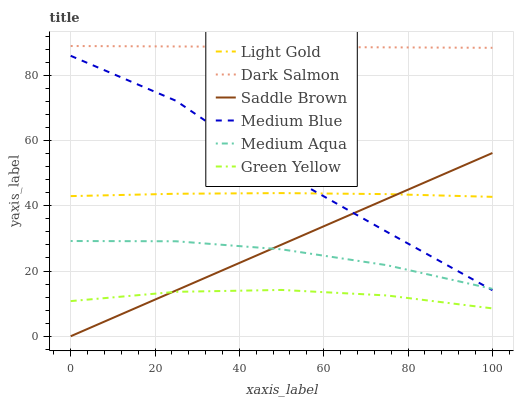Does Green Yellow have the minimum area under the curve?
Answer yes or no. Yes. Does Dark Salmon have the maximum area under the curve?
Answer yes or no. Yes. Does Medium Aqua have the minimum area under the curve?
Answer yes or no. No. Does Medium Aqua have the maximum area under the curve?
Answer yes or no. No. Is Dark Salmon the smoothest?
Answer yes or no. Yes. Is Medium Blue the roughest?
Answer yes or no. Yes. Is Medium Aqua the smoothest?
Answer yes or no. No. Is Medium Aqua the roughest?
Answer yes or no. No. Does Saddle Brown have the lowest value?
Answer yes or no. Yes. Does Medium Aqua have the lowest value?
Answer yes or no. No. Does Dark Salmon have the highest value?
Answer yes or no. Yes. Does Medium Aqua have the highest value?
Answer yes or no. No. Is Green Yellow less than Light Gold?
Answer yes or no. Yes. Is Dark Salmon greater than Green Yellow?
Answer yes or no. Yes. Does Medium Aqua intersect Saddle Brown?
Answer yes or no. Yes. Is Medium Aqua less than Saddle Brown?
Answer yes or no. No. Is Medium Aqua greater than Saddle Brown?
Answer yes or no. No. Does Green Yellow intersect Light Gold?
Answer yes or no. No. 